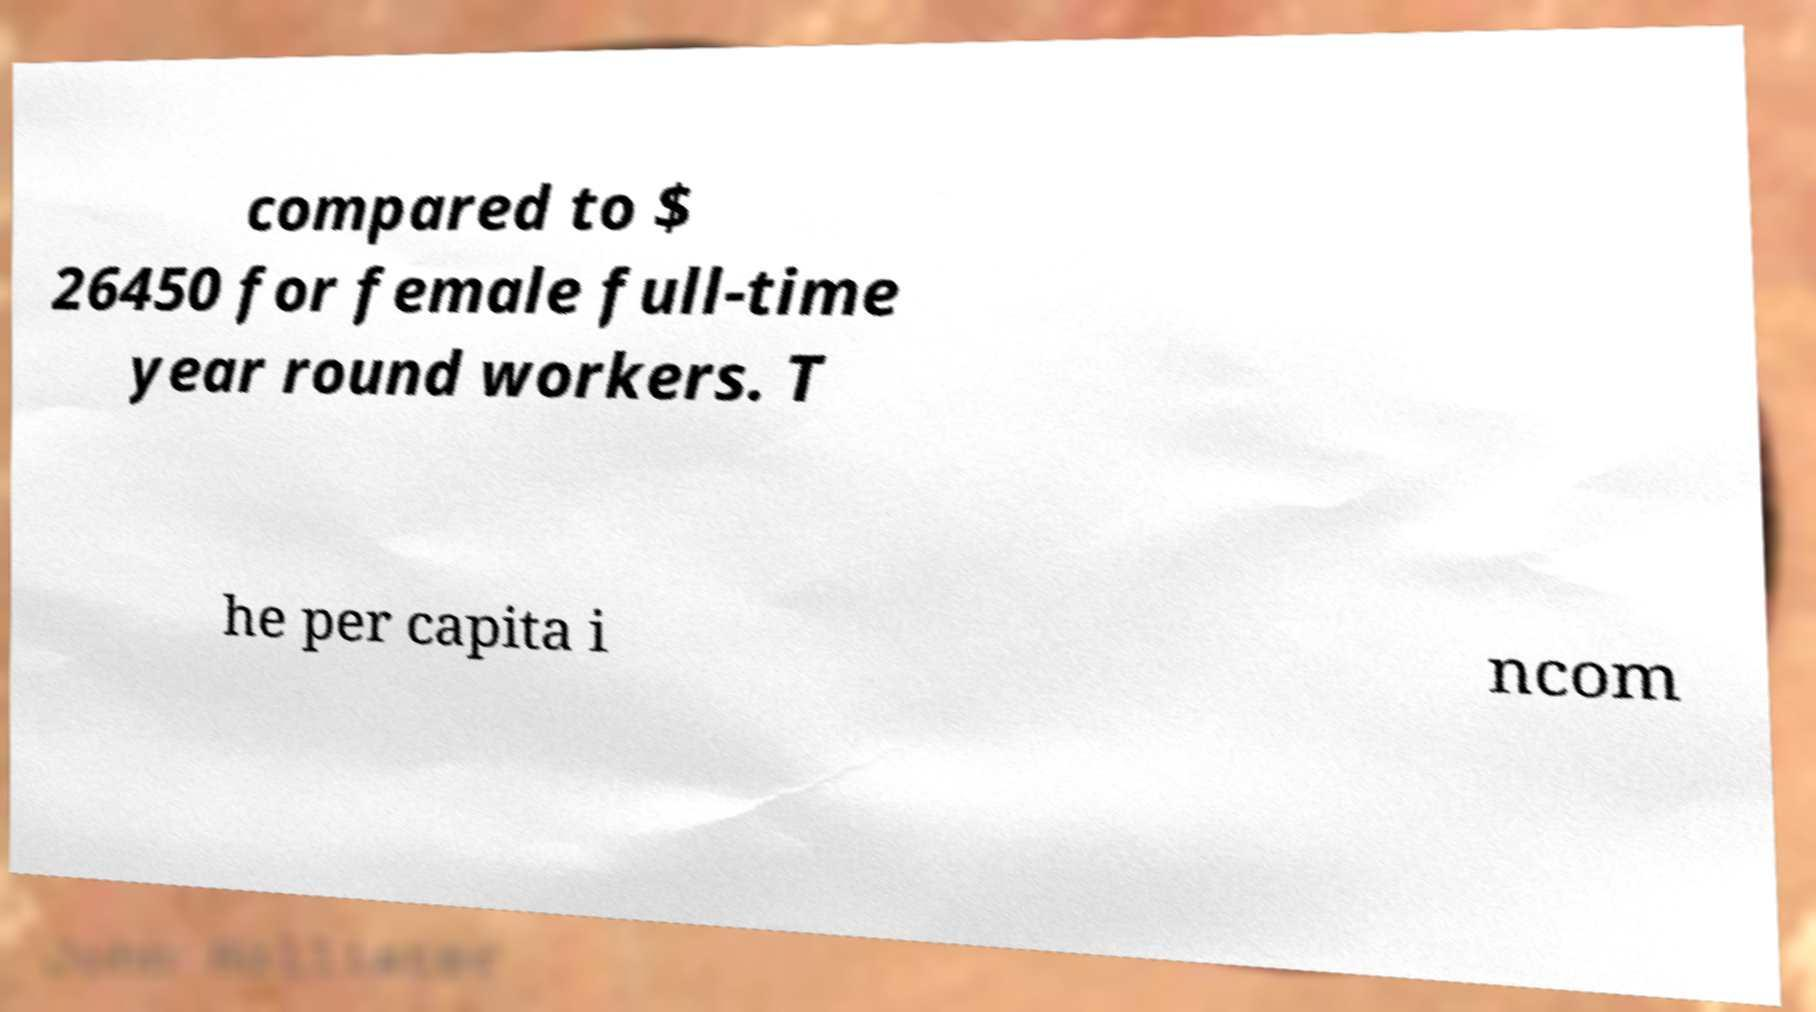Can you accurately transcribe the text from the provided image for me? compared to $ 26450 for female full-time year round workers. T he per capita i ncom 